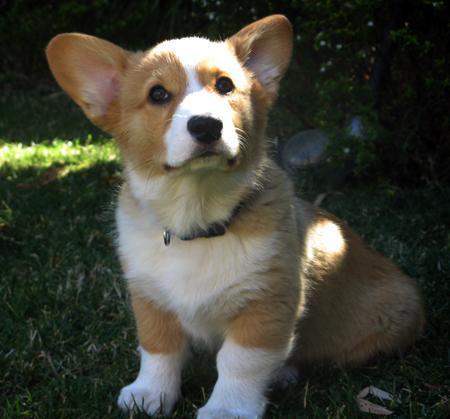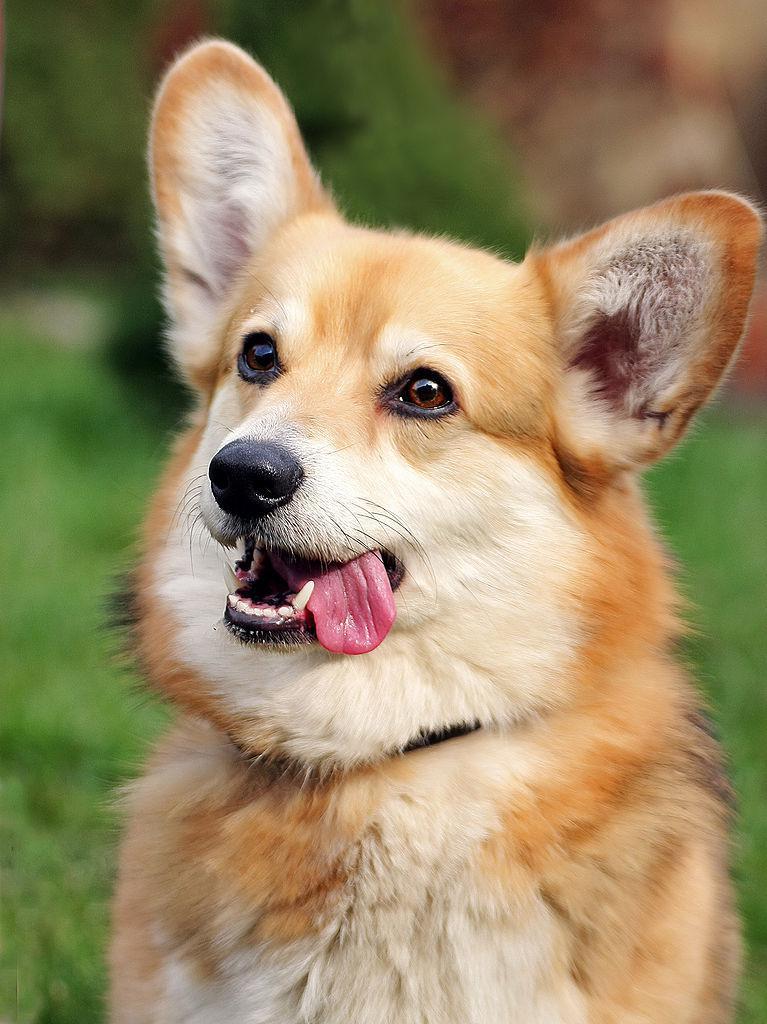The first image is the image on the left, the second image is the image on the right. Given the left and right images, does the statement "the tongue is out on the dogs wide open mouth" hold true? Answer yes or no. Yes. The first image is the image on the left, the second image is the image on the right. For the images shown, is this caption "An image shows an open-mouthed corgi dog that does not have its tongue hanging to one side." true? Answer yes or no. No. 